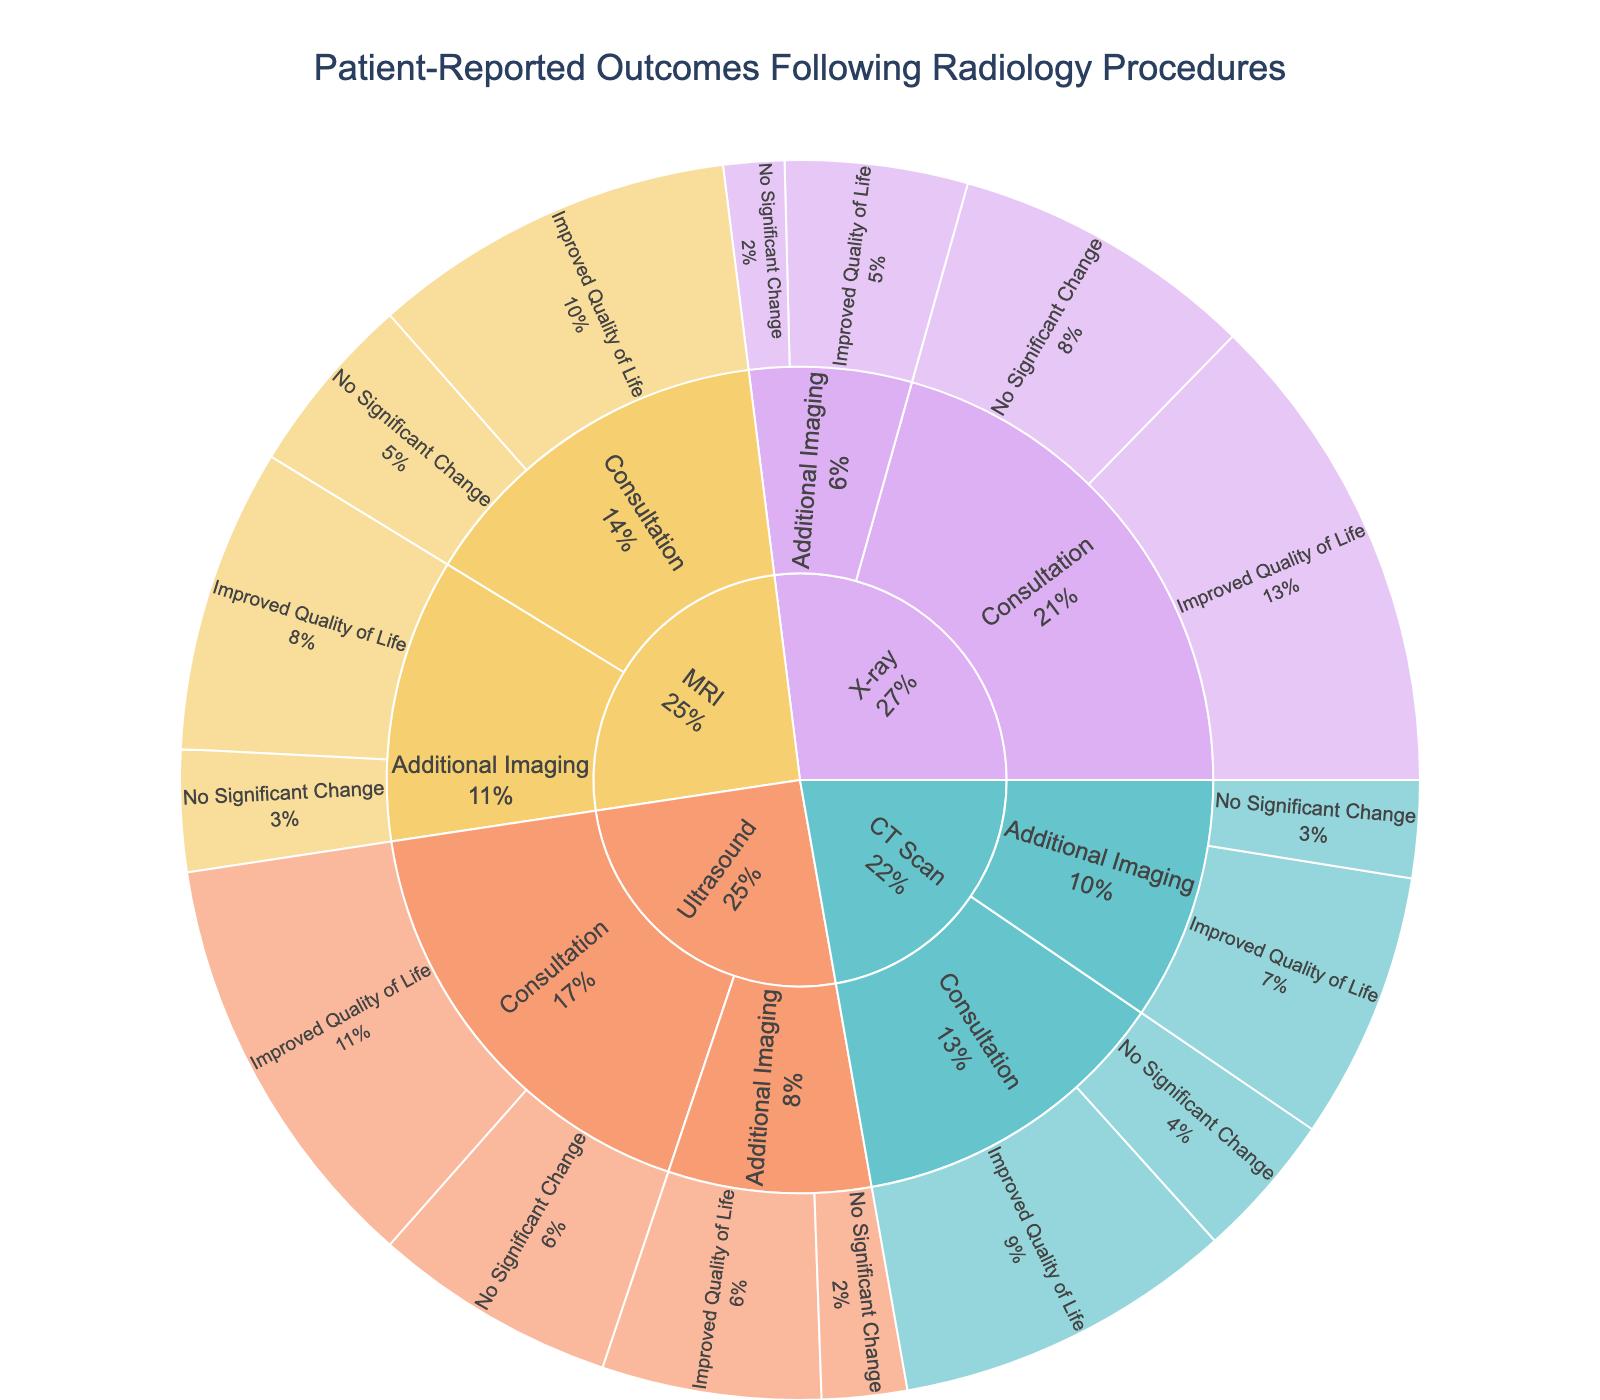How many patient-reported outcomes involve MRI procedures? To find the number of outcomes for MRI, sum all corresponding values: 30 (Consultation, Improved Quality of Life) + 15 (Consultation, No Significant Change) + 25 (Additional Imaging, Improved Quality of Life) + 10 (Additional Imaging, No Significant Change)
Answer: 80 What is the most common follow-up care across all procedures? Look at the proportions of each follow-up care type (Consultation and Additional Imaging) across all procedures. The highest percentage will indicate the most common follow-up care
Answer: Consultation Which combination of procedure and follow-up care results in the highest reported 'Improved Quality of Life'? Identify the combination by comparing the values reported for 'Improved Quality of Life' across all procedure and follow-up care types. The highest value corresponds to X-ray with Consultation
Answer: X-ray with Consultation How does the number of 'No Significant Change' outcomes compare between CT Scan and Ultrasound? Look at the total 'No Significant Change' outcomes for CT Scan (12 Consultation + 8 Additional Imaging = 20) and for Ultrasound (20 Consultation + 7 Additional Imaging = 27), and compare them
Answer: Ultrasound has more What percentage of patients undergoing X-rays reported an improved quality of life following additional imaging? The value for X-ray with Additional Imaging and Improved Quality of Life is 15. Sum all values for X-ray: 40 (Consultation, Improved QoL) + 25 (Consultation, No Significant Change) + 15 (Additional Imaging, Improved QoL) + 5 (Additional Imaging, No Significant Change) = 85. Calculate the percentage: (15/85) * 100
Answer: 17.6% Which procedure has the lowest reported outcomes for 'No Significant Change' following consultations? Compare the values for 'No Significant Change' following consultations across all procedures: MRI (15), CT Scan (12), Ultrasound (20), and X-ray (25). The lowest is for CT Scan
Answer: CT Scan Is there a greater number of 'Improved Quality of Life' outcomes from consultations or additional imaging for Ultrasound procedures? Sum the values for 'Improved Quality of Life' outcomes from consultations (35) and from additional imaging (18) for Ultrasound. Compare them
Answer: Consultations have more What is the total number of patient-reported outcomes for CT Scan procedures? Add all values for CT Scan procedures: 28 (Consultation, Improved QoL) + 12 (Consultation, No Significant Change) + 22 (Additional Imaging, Improved QoL) + 8 (Additional Imaging, No Significant Change)
Answer: 70 